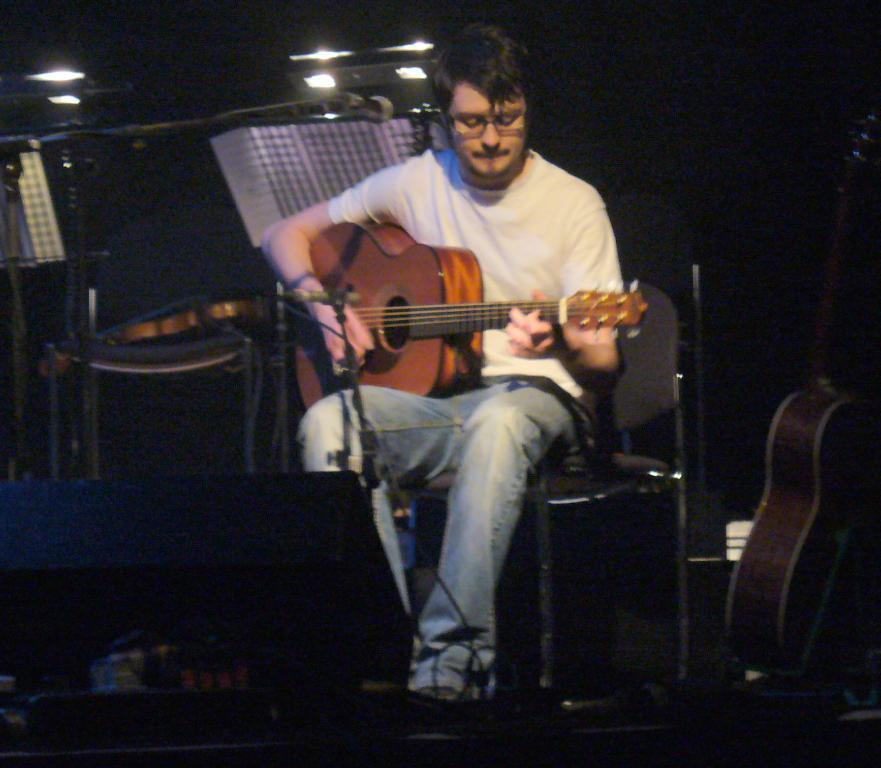How would you summarize this image in a sentence or two? In the center of the image there is a man sitting on the chair. She is playing a guitar. There is a mic placed before him. On the right there is a guitar. At the top there are lights. 